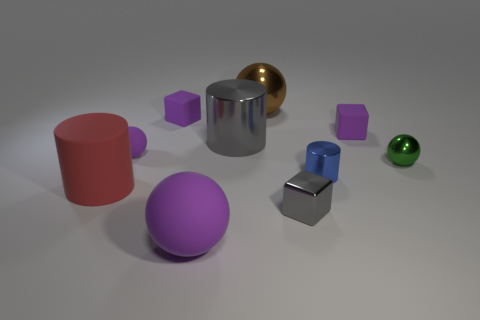Subtract all metallic cylinders. How many cylinders are left? 1 Subtract all red cylinders. How many cylinders are left? 2 Subtract all cyan cylinders. How many purple spheres are left? 2 Add 7 purple blocks. How many purple blocks are left? 9 Add 8 blue metallic objects. How many blue metallic objects exist? 9 Subtract 0 cyan cylinders. How many objects are left? 10 Subtract all balls. How many objects are left? 6 Subtract 2 blocks. How many blocks are left? 1 Subtract all yellow balls. Subtract all red blocks. How many balls are left? 4 Subtract all large red metal cylinders. Subtract all green metal objects. How many objects are left? 9 